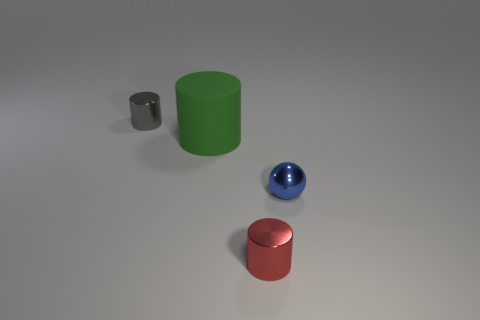Add 1 small blue things. How many objects exist? 5 Subtract all balls. How many objects are left? 3 Subtract 1 green cylinders. How many objects are left? 3 Subtract all shiny cylinders. Subtract all small red shiny cylinders. How many objects are left? 1 Add 1 large cylinders. How many large cylinders are left? 2 Add 3 large cyan things. How many large cyan things exist? 3 